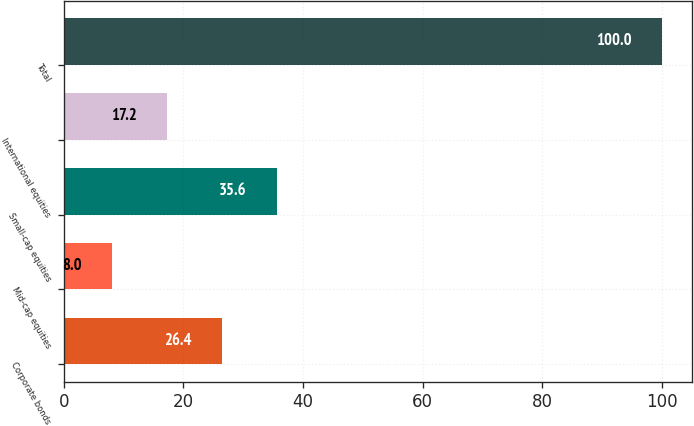Convert chart to OTSL. <chart><loc_0><loc_0><loc_500><loc_500><bar_chart><fcel>Corporate bonds<fcel>Mid-cap equities<fcel>Small-cap equities<fcel>International equities<fcel>Total<nl><fcel>26.4<fcel>8<fcel>35.6<fcel>17.2<fcel>100<nl></chart> 